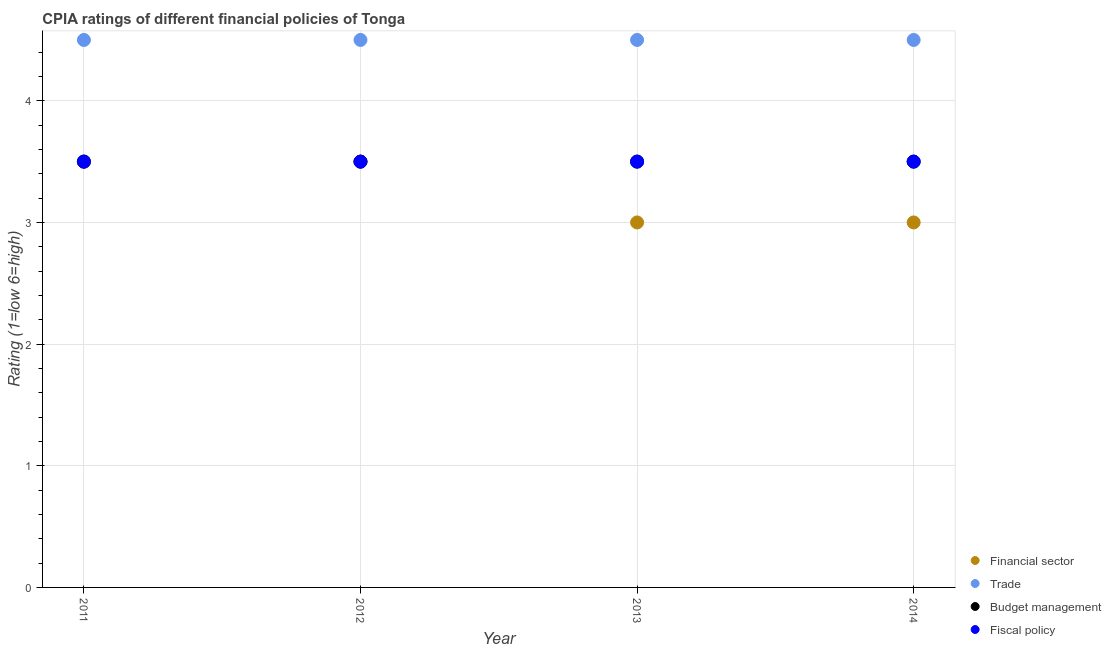Is the number of dotlines equal to the number of legend labels?
Your answer should be compact. Yes. What is the cpia rating of budget management in 2011?
Your answer should be compact. 3.5. Across all years, what is the minimum cpia rating of trade?
Provide a succinct answer. 4.5. In which year was the cpia rating of budget management maximum?
Make the answer very short. 2011. In which year was the cpia rating of trade minimum?
Your answer should be very brief. 2011. What is the total cpia rating of budget management in the graph?
Offer a very short reply. 14. In the year 2011, what is the difference between the cpia rating of trade and cpia rating of financial sector?
Your answer should be compact. 1. In how many years, is the cpia rating of financial sector greater than 3?
Your response must be concise. 2. Is the cpia rating of trade in 2011 less than that in 2013?
Provide a succinct answer. No. What is the difference between the highest and the second highest cpia rating of financial sector?
Keep it short and to the point. 0. What is the difference between the highest and the lowest cpia rating of trade?
Give a very brief answer. 0. In how many years, is the cpia rating of trade greater than the average cpia rating of trade taken over all years?
Provide a short and direct response. 0. Is it the case that in every year, the sum of the cpia rating of financial sector and cpia rating of trade is greater than the sum of cpia rating of fiscal policy and cpia rating of budget management?
Keep it short and to the point. No. Is the cpia rating of trade strictly less than the cpia rating of budget management over the years?
Your answer should be very brief. No. How many years are there in the graph?
Provide a succinct answer. 4. Are the values on the major ticks of Y-axis written in scientific E-notation?
Your answer should be very brief. No. Where does the legend appear in the graph?
Keep it short and to the point. Bottom right. How many legend labels are there?
Give a very brief answer. 4. How are the legend labels stacked?
Give a very brief answer. Vertical. What is the title of the graph?
Your answer should be compact. CPIA ratings of different financial policies of Tonga. What is the label or title of the X-axis?
Offer a terse response. Year. What is the label or title of the Y-axis?
Your response must be concise. Rating (1=low 6=high). What is the Rating (1=low 6=high) in Financial sector in 2011?
Make the answer very short. 3.5. What is the Rating (1=low 6=high) in Trade in 2011?
Keep it short and to the point. 4.5. What is the Rating (1=low 6=high) of Budget management in 2011?
Ensure brevity in your answer.  3.5. What is the Rating (1=low 6=high) in Fiscal policy in 2011?
Your response must be concise. 3.5. What is the Rating (1=low 6=high) of Fiscal policy in 2012?
Provide a succinct answer. 3.5. What is the Rating (1=low 6=high) of Financial sector in 2013?
Provide a succinct answer. 3. What is the Rating (1=low 6=high) in Fiscal policy in 2013?
Ensure brevity in your answer.  3.5. What is the Rating (1=low 6=high) in Budget management in 2014?
Your answer should be compact. 3.5. Across all years, what is the maximum Rating (1=low 6=high) of Fiscal policy?
Offer a very short reply. 3.5. Across all years, what is the minimum Rating (1=low 6=high) in Financial sector?
Ensure brevity in your answer.  3. Across all years, what is the minimum Rating (1=low 6=high) of Fiscal policy?
Ensure brevity in your answer.  3.5. What is the total Rating (1=low 6=high) of Financial sector in the graph?
Make the answer very short. 13. What is the total Rating (1=low 6=high) of Trade in the graph?
Give a very brief answer. 18. What is the total Rating (1=low 6=high) of Budget management in the graph?
Provide a succinct answer. 14. What is the total Rating (1=low 6=high) of Fiscal policy in the graph?
Your answer should be compact. 14. What is the difference between the Rating (1=low 6=high) of Financial sector in 2011 and that in 2012?
Ensure brevity in your answer.  0. What is the difference between the Rating (1=low 6=high) of Trade in 2011 and that in 2012?
Give a very brief answer. 0. What is the difference between the Rating (1=low 6=high) of Trade in 2011 and that in 2013?
Your response must be concise. 0. What is the difference between the Rating (1=low 6=high) of Financial sector in 2011 and that in 2014?
Offer a terse response. 0.5. What is the difference between the Rating (1=low 6=high) of Trade in 2011 and that in 2014?
Give a very brief answer. 0. What is the difference between the Rating (1=low 6=high) in Fiscal policy in 2011 and that in 2014?
Ensure brevity in your answer.  0. What is the difference between the Rating (1=low 6=high) of Financial sector in 2012 and that in 2013?
Your answer should be compact. 0.5. What is the difference between the Rating (1=low 6=high) of Budget management in 2012 and that in 2013?
Your answer should be very brief. 0. What is the difference between the Rating (1=low 6=high) in Fiscal policy in 2012 and that in 2013?
Provide a succinct answer. 0. What is the difference between the Rating (1=low 6=high) of Trade in 2012 and that in 2014?
Make the answer very short. 0. What is the difference between the Rating (1=low 6=high) of Fiscal policy in 2012 and that in 2014?
Make the answer very short. 0. What is the difference between the Rating (1=low 6=high) of Financial sector in 2013 and that in 2014?
Offer a very short reply. 0. What is the difference between the Rating (1=low 6=high) in Fiscal policy in 2013 and that in 2014?
Make the answer very short. 0. What is the difference between the Rating (1=low 6=high) of Financial sector in 2011 and the Rating (1=low 6=high) of Trade in 2012?
Provide a succinct answer. -1. What is the difference between the Rating (1=low 6=high) in Financial sector in 2011 and the Rating (1=low 6=high) in Budget management in 2012?
Your response must be concise. 0. What is the difference between the Rating (1=low 6=high) of Financial sector in 2011 and the Rating (1=low 6=high) of Fiscal policy in 2012?
Keep it short and to the point. 0. What is the difference between the Rating (1=low 6=high) in Trade in 2011 and the Rating (1=low 6=high) in Budget management in 2012?
Provide a succinct answer. 1. What is the difference between the Rating (1=low 6=high) of Trade in 2011 and the Rating (1=low 6=high) of Fiscal policy in 2012?
Your answer should be compact. 1. What is the difference between the Rating (1=low 6=high) of Financial sector in 2011 and the Rating (1=low 6=high) of Trade in 2013?
Your response must be concise. -1. What is the difference between the Rating (1=low 6=high) of Financial sector in 2011 and the Rating (1=low 6=high) of Budget management in 2013?
Offer a terse response. 0. What is the difference between the Rating (1=low 6=high) in Financial sector in 2011 and the Rating (1=low 6=high) in Fiscal policy in 2013?
Provide a short and direct response. 0. What is the difference between the Rating (1=low 6=high) in Trade in 2011 and the Rating (1=low 6=high) in Budget management in 2013?
Make the answer very short. 1. What is the difference between the Rating (1=low 6=high) in Trade in 2011 and the Rating (1=low 6=high) in Fiscal policy in 2013?
Provide a succinct answer. 1. What is the difference between the Rating (1=low 6=high) in Budget management in 2011 and the Rating (1=low 6=high) in Fiscal policy in 2013?
Offer a very short reply. 0. What is the difference between the Rating (1=low 6=high) of Financial sector in 2011 and the Rating (1=low 6=high) of Trade in 2014?
Your response must be concise. -1. What is the difference between the Rating (1=low 6=high) in Budget management in 2011 and the Rating (1=low 6=high) in Fiscal policy in 2014?
Provide a short and direct response. 0. What is the difference between the Rating (1=low 6=high) in Financial sector in 2012 and the Rating (1=low 6=high) in Budget management in 2013?
Offer a terse response. 0. What is the difference between the Rating (1=low 6=high) of Financial sector in 2012 and the Rating (1=low 6=high) of Fiscal policy in 2013?
Make the answer very short. 0. What is the difference between the Rating (1=low 6=high) of Trade in 2012 and the Rating (1=low 6=high) of Fiscal policy in 2013?
Make the answer very short. 1. What is the difference between the Rating (1=low 6=high) of Budget management in 2012 and the Rating (1=low 6=high) of Fiscal policy in 2013?
Offer a terse response. 0. What is the difference between the Rating (1=low 6=high) of Financial sector in 2012 and the Rating (1=low 6=high) of Budget management in 2014?
Your response must be concise. 0. What is the difference between the Rating (1=low 6=high) in Trade in 2012 and the Rating (1=low 6=high) in Budget management in 2014?
Offer a terse response. 1. What is the difference between the Rating (1=low 6=high) in Budget management in 2012 and the Rating (1=low 6=high) in Fiscal policy in 2014?
Keep it short and to the point. 0. What is the difference between the Rating (1=low 6=high) of Budget management in 2013 and the Rating (1=low 6=high) of Fiscal policy in 2014?
Keep it short and to the point. 0. What is the average Rating (1=low 6=high) of Budget management per year?
Offer a terse response. 3.5. What is the average Rating (1=low 6=high) in Fiscal policy per year?
Give a very brief answer. 3.5. In the year 2011, what is the difference between the Rating (1=low 6=high) of Financial sector and Rating (1=low 6=high) of Trade?
Provide a succinct answer. -1. In the year 2011, what is the difference between the Rating (1=low 6=high) of Budget management and Rating (1=low 6=high) of Fiscal policy?
Provide a succinct answer. 0. In the year 2012, what is the difference between the Rating (1=low 6=high) of Financial sector and Rating (1=low 6=high) of Trade?
Make the answer very short. -1. In the year 2012, what is the difference between the Rating (1=low 6=high) of Financial sector and Rating (1=low 6=high) of Budget management?
Provide a short and direct response. 0. In the year 2012, what is the difference between the Rating (1=low 6=high) in Trade and Rating (1=low 6=high) in Budget management?
Provide a short and direct response. 1. In the year 2012, what is the difference between the Rating (1=low 6=high) in Trade and Rating (1=low 6=high) in Fiscal policy?
Make the answer very short. 1. In the year 2012, what is the difference between the Rating (1=low 6=high) of Budget management and Rating (1=low 6=high) of Fiscal policy?
Ensure brevity in your answer.  0. In the year 2013, what is the difference between the Rating (1=low 6=high) of Financial sector and Rating (1=low 6=high) of Budget management?
Keep it short and to the point. -0.5. In the year 2013, what is the difference between the Rating (1=low 6=high) of Financial sector and Rating (1=low 6=high) of Fiscal policy?
Provide a succinct answer. -0.5. In the year 2013, what is the difference between the Rating (1=low 6=high) in Trade and Rating (1=low 6=high) in Budget management?
Your response must be concise. 1. In the year 2013, what is the difference between the Rating (1=low 6=high) in Trade and Rating (1=low 6=high) in Fiscal policy?
Keep it short and to the point. 1. In the year 2014, what is the difference between the Rating (1=low 6=high) of Financial sector and Rating (1=low 6=high) of Fiscal policy?
Keep it short and to the point. -0.5. In the year 2014, what is the difference between the Rating (1=low 6=high) in Trade and Rating (1=low 6=high) in Budget management?
Ensure brevity in your answer.  1. In the year 2014, what is the difference between the Rating (1=low 6=high) of Budget management and Rating (1=low 6=high) of Fiscal policy?
Your response must be concise. 0. What is the ratio of the Rating (1=low 6=high) of Trade in 2011 to that in 2012?
Keep it short and to the point. 1. What is the ratio of the Rating (1=low 6=high) of Budget management in 2011 to that in 2012?
Offer a terse response. 1. What is the ratio of the Rating (1=low 6=high) of Fiscal policy in 2011 to that in 2013?
Make the answer very short. 1. What is the ratio of the Rating (1=low 6=high) in Fiscal policy in 2011 to that in 2014?
Offer a very short reply. 1. What is the ratio of the Rating (1=low 6=high) in Trade in 2012 to that in 2013?
Provide a succinct answer. 1. What is the ratio of the Rating (1=low 6=high) of Fiscal policy in 2012 to that in 2013?
Your response must be concise. 1. What is the ratio of the Rating (1=low 6=high) in Financial sector in 2012 to that in 2014?
Your response must be concise. 1.17. What is the ratio of the Rating (1=low 6=high) in Budget management in 2012 to that in 2014?
Provide a succinct answer. 1. What is the ratio of the Rating (1=low 6=high) of Financial sector in 2013 to that in 2014?
Make the answer very short. 1. What is the ratio of the Rating (1=low 6=high) of Budget management in 2013 to that in 2014?
Ensure brevity in your answer.  1. What is the difference between the highest and the second highest Rating (1=low 6=high) of Financial sector?
Provide a succinct answer. 0. What is the difference between the highest and the second highest Rating (1=low 6=high) in Budget management?
Your answer should be compact. 0. 